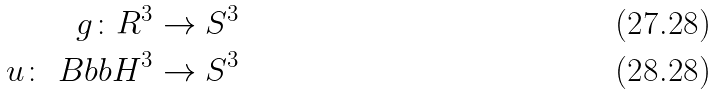Convert formula to latex. <formula><loc_0><loc_0><loc_500><loc_500>g \colon R ^ { 3 } \rightarrow S ^ { 3 } \\ u \colon \ B b b H ^ { 3 } \rightarrow S ^ { 3 }</formula> 